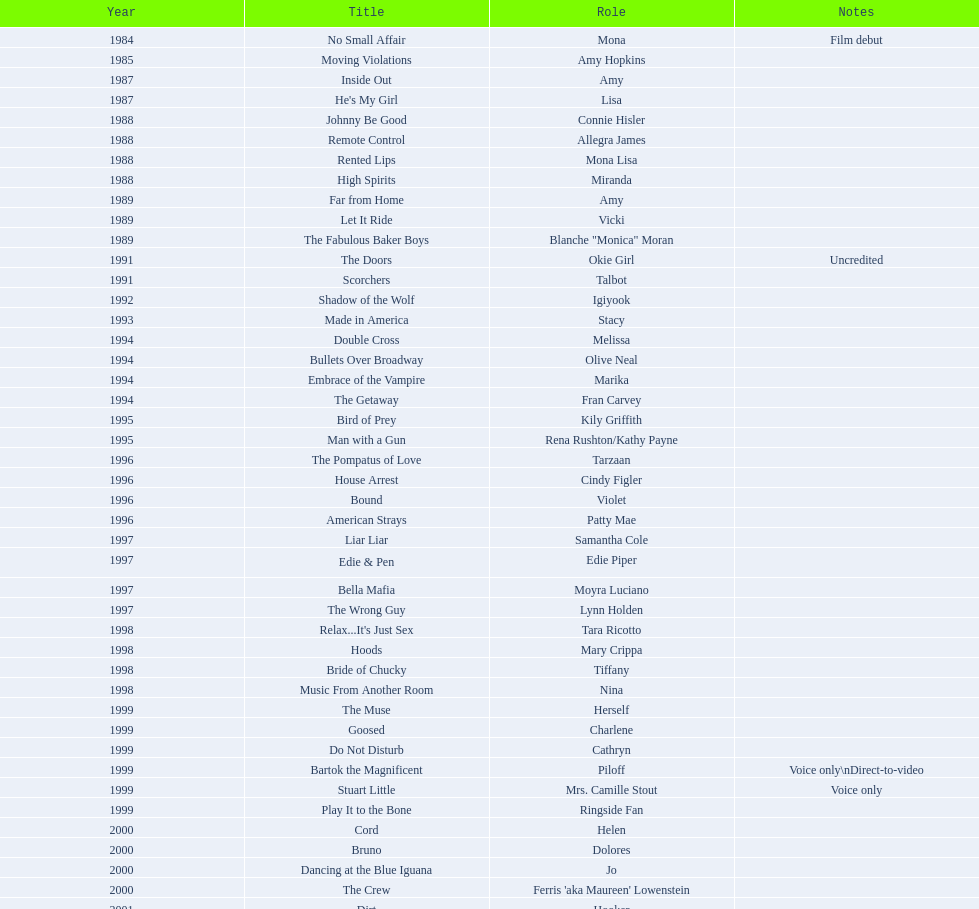Which film has their role under igiyook? Shadow of the Wolf. 